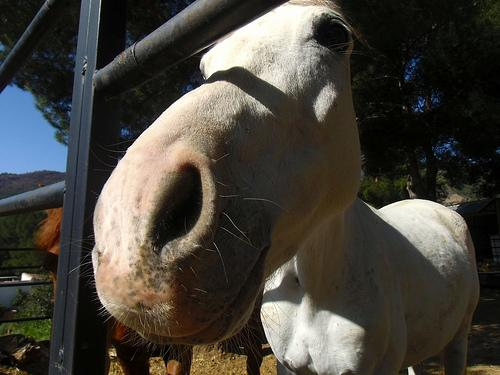Question: what animal is in the photo?
Choices:
A. Horse.
B. Burro.
C. Zebra.
D. Donkey.
Answer with the letter. Answer: D Question: who is standing next to the donkey?
Choices:
A. No one.
B. A dog.
C. A mule.
D. A horse.
Answer with the letter. Answer: A 